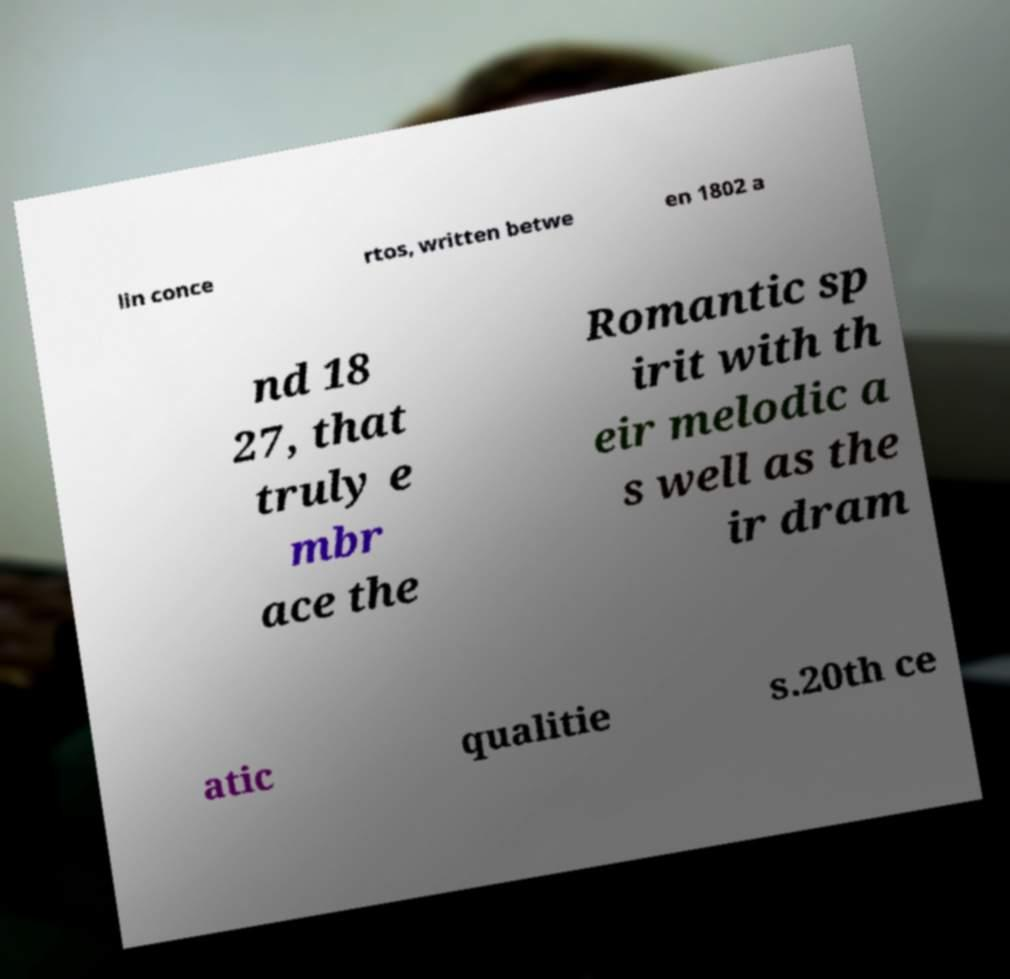Can you read and provide the text displayed in the image?This photo seems to have some interesting text. Can you extract and type it out for me? lin conce rtos, written betwe en 1802 a nd 18 27, that truly e mbr ace the Romantic sp irit with th eir melodic a s well as the ir dram atic qualitie s.20th ce 